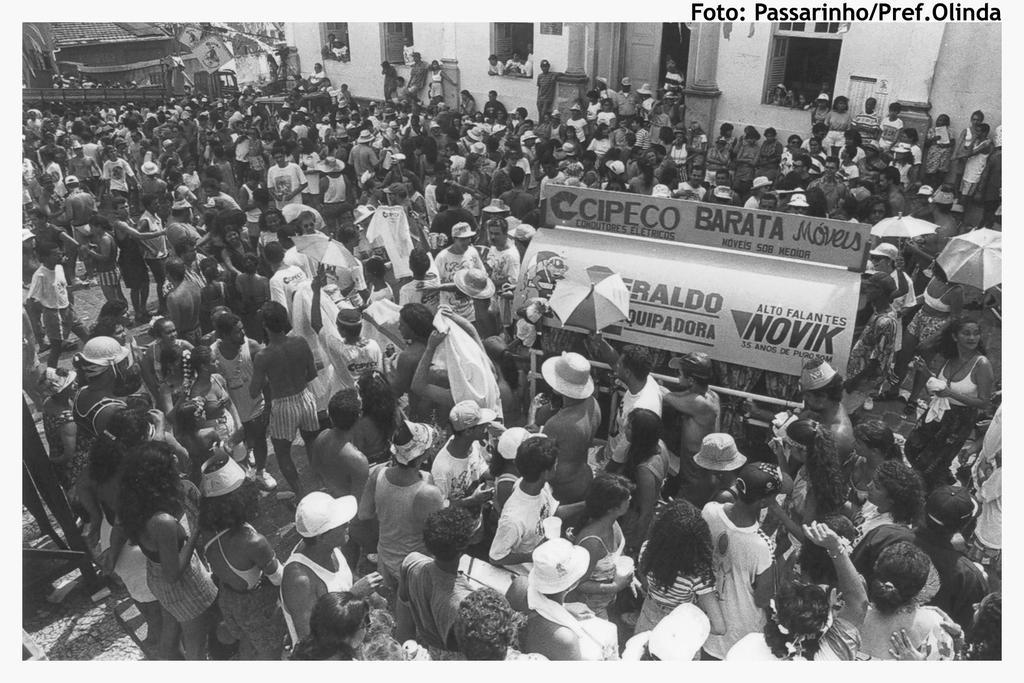Can you describe this image briefly? In this image we can see a group of people and among them few persons are holding few objects. In the middle we can see an object with text written on it. Behind the persons we can see a few houses. In the top right, we can see some text. 